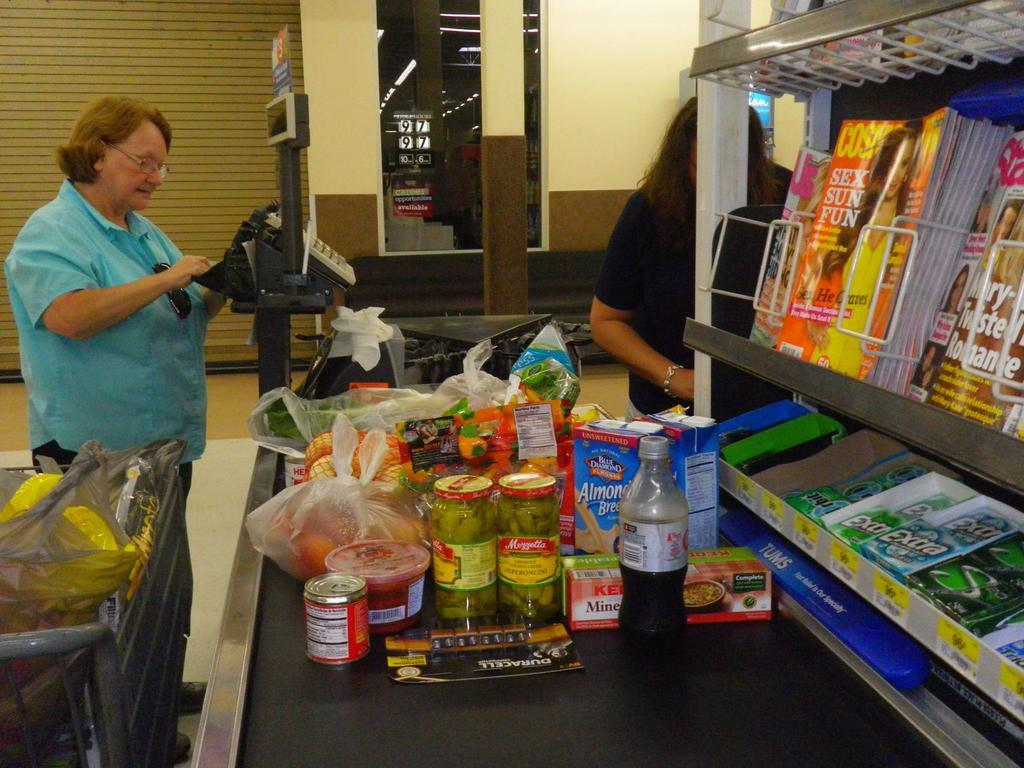Provide a one-sentence caption for the provided image. Check out lane with a magazine display featuring Cosmopolitan. 